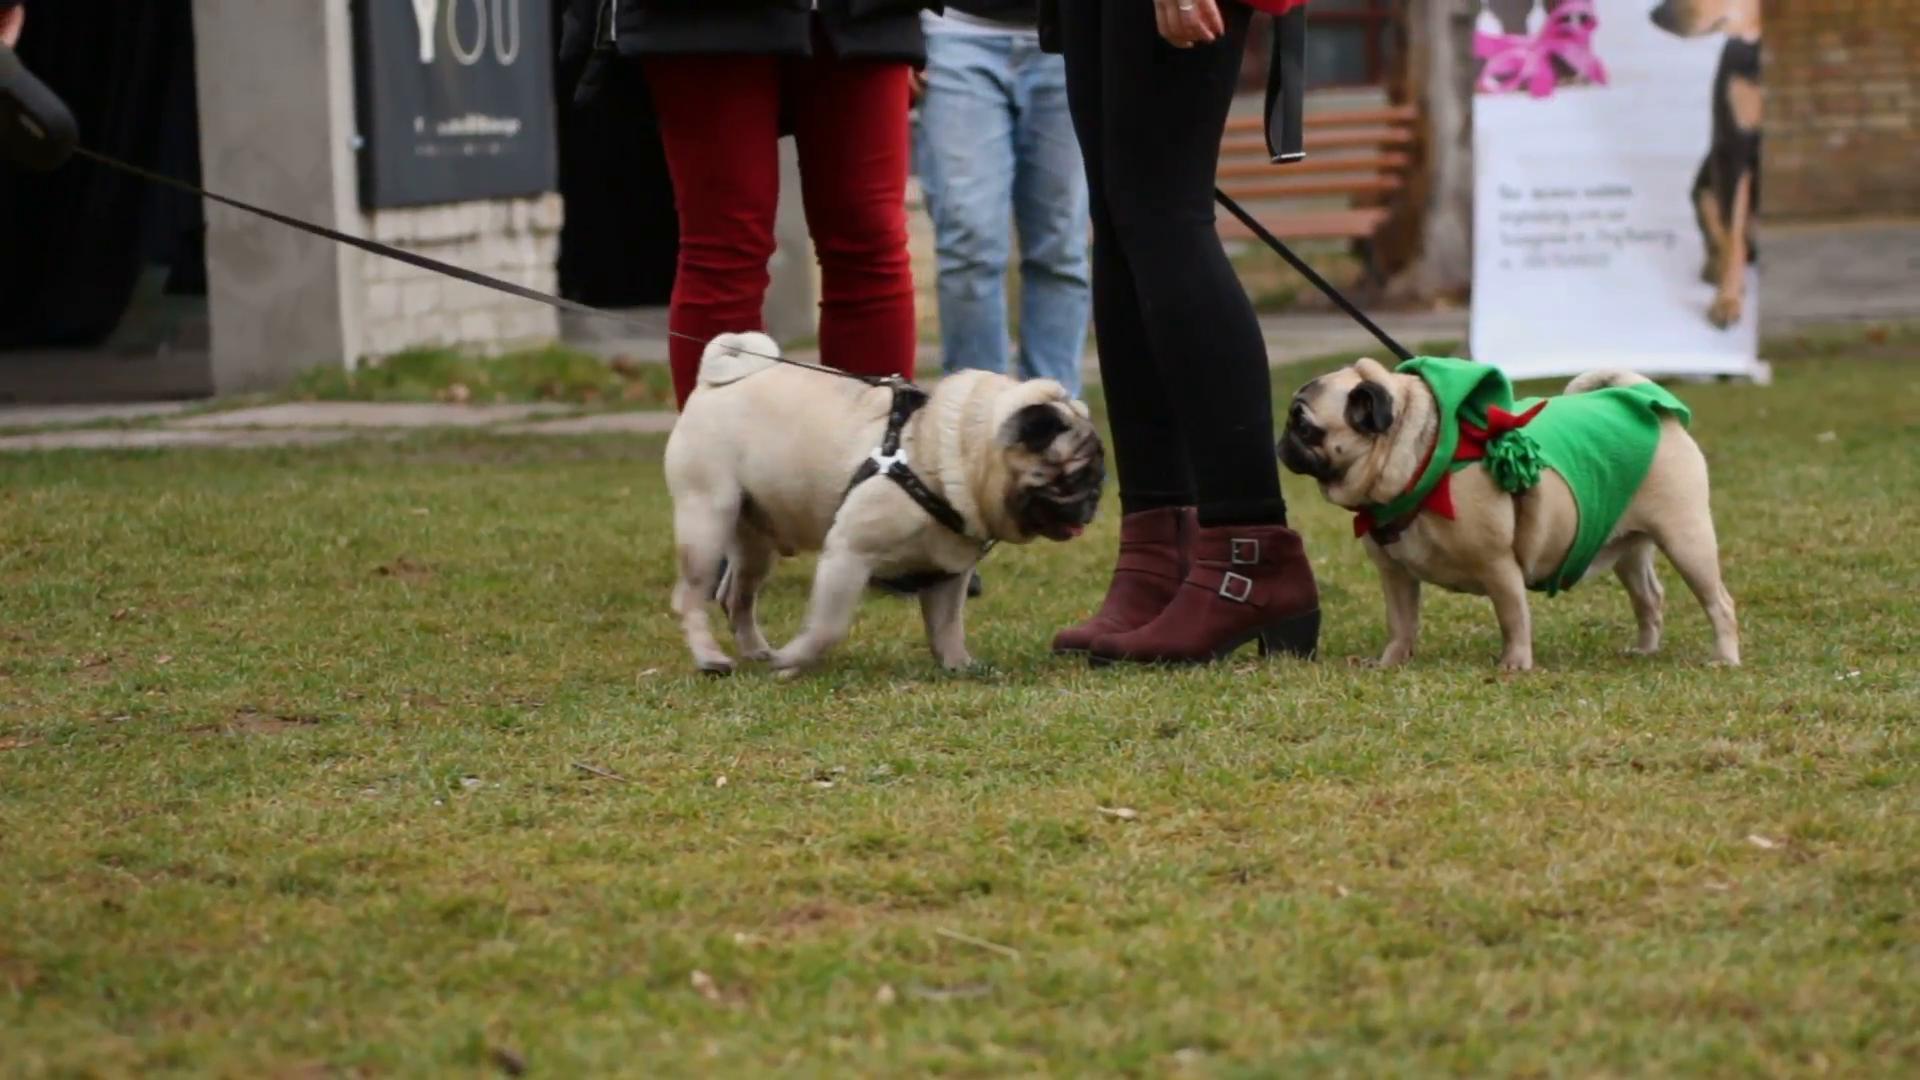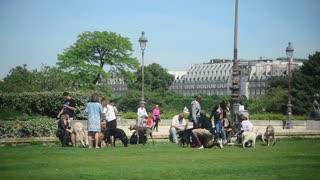The first image is the image on the left, the second image is the image on the right. Analyze the images presented: Is the assertion "One image contains fewer than 3 pugs, and all pugs are on a leash." valid? Answer yes or no. Yes. 